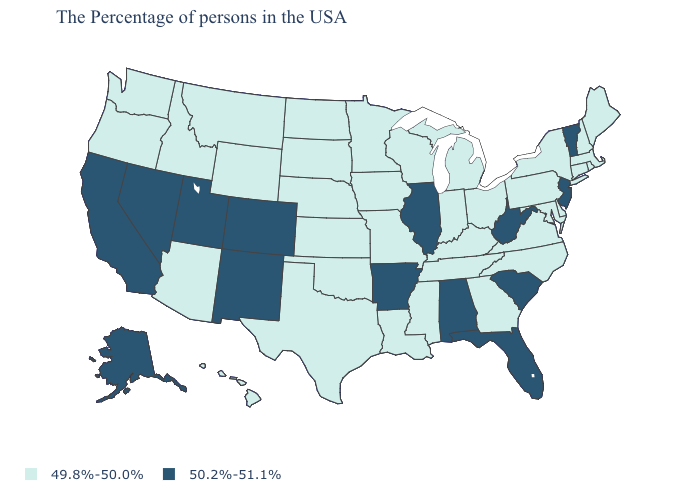Does the map have missing data?
Write a very short answer. No. Does the first symbol in the legend represent the smallest category?
Write a very short answer. Yes. What is the value of Missouri?
Short answer required. 49.8%-50.0%. Among the states that border Virginia , does West Virginia have the highest value?
Short answer required. Yes. Name the states that have a value in the range 49.8%-50.0%?
Answer briefly. Maine, Massachusetts, Rhode Island, New Hampshire, Connecticut, New York, Delaware, Maryland, Pennsylvania, Virginia, North Carolina, Ohio, Georgia, Michigan, Kentucky, Indiana, Tennessee, Wisconsin, Mississippi, Louisiana, Missouri, Minnesota, Iowa, Kansas, Nebraska, Oklahoma, Texas, South Dakota, North Dakota, Wyoming, Montana, Arizona, Idaho, Washington, Oregon, Hawaii. Does the first symbol in the legend represent the smallest category?
Quick response, please. Yes. What is the lowest value in states that border Oklahoma?
Be succinct. 49.8%-50.0%. What is the lowest value in the Northeast?
Short answer required. 49.8%-50.0%. Does Illinois have the highest value in the USA?
Give a very brief answer. Yes. Which states have the lowest value in the USA?
Answer briefly. Maine, Massachusetts, Rhode Island, New Hampshire, Connecticut, New York, Delaware, Maryland, Pennsylvania, Virginia, North Carolina, Ohio, Georgia, Michigan, Kentucky, Indiana, Tennessee, Wisconsin, Mississippi, Louisiana, Missouri, Minnesota, Iowa, Kansas, Nebraska, Oklahoma, Texas, South Dakota, North Dakota, Wyoming, Montana, Arizona, Idaho, Washington, Oregon, Hawaii. Among the states that border Minnesota , which have the highest value?
Give a very brief answer. Wisconsin, Iowa, South Dakota, North Dakota. Name the states that have a value in the range 49.8%-50.0%?
Be succinct. Maine, Massachusetts, Rhode Island, New Hampshire, Connecticut, New York, Delaware, Maryland, Pennsylvania, Virginia, North Carolina, Ohio, Georgia, Michigan, Kentucky, Indiana, Tennessee, Wisconsin, Mississippi, Louisiana, Missouri, Minnesota, Iowa, Kansas, Nebraska, Oklahoma, Texas, South Dakota, North Dakota, Wyoming, Montana, Arizona, Idaho, Washington, Oregon, Hawaii. What is the lowest value in the Northeast?
Write a very short answer. 49.8%-50.0%. Name the states that have a value in the range 50.2%-51.1%?
Quick response, please. Vermont, New Jersey, South Carolina, West Virginia, Florida, Alabama, Illinois, Arkansas, Colorado, New Mexico, Utah, Nevada, California, Alaska. What is the lowest value in states that border Pennsylvania?
Answer briefly. 49.8%-50.0%. 